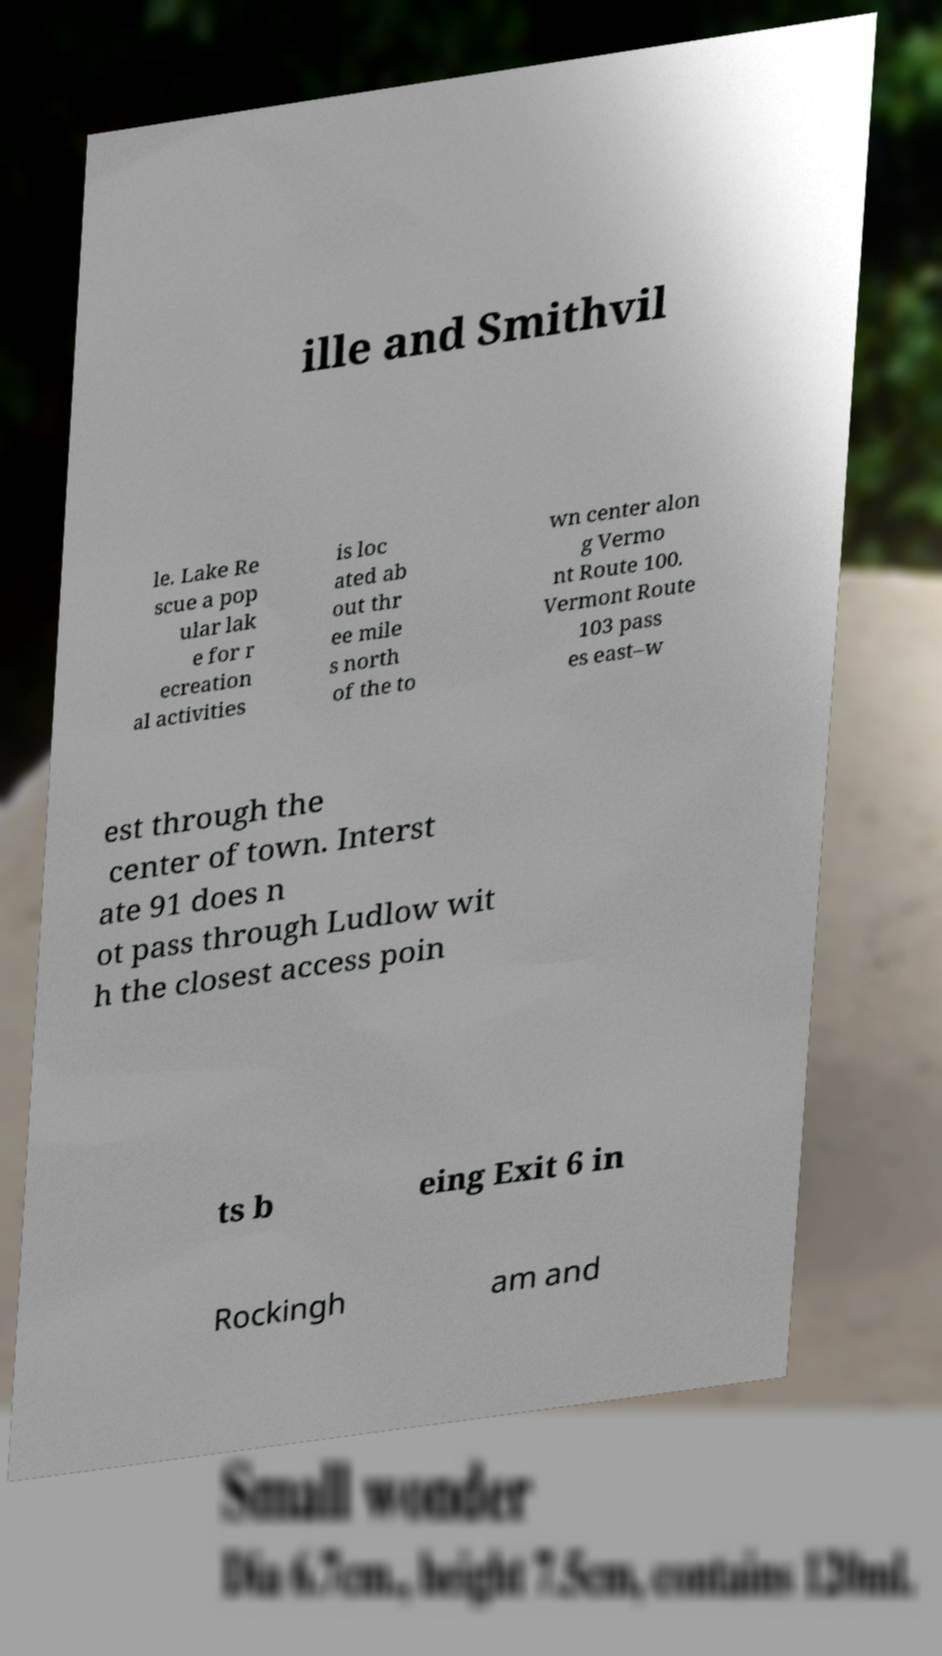Could you extract and type out the text from this image? ille and Smithvil le. Lake Re scue a pop ular lak e for r ecreation al activities is loc ated ab out thr ee mile s north of the to wn center alon g Vermo nt Route 100. Vermont Route 103 pass es east–w est through the center of town. Interst ate 91 does n ot pass through Ludlow wit h the closest access poin ts b eing Exit 6 in Rockingh am and 